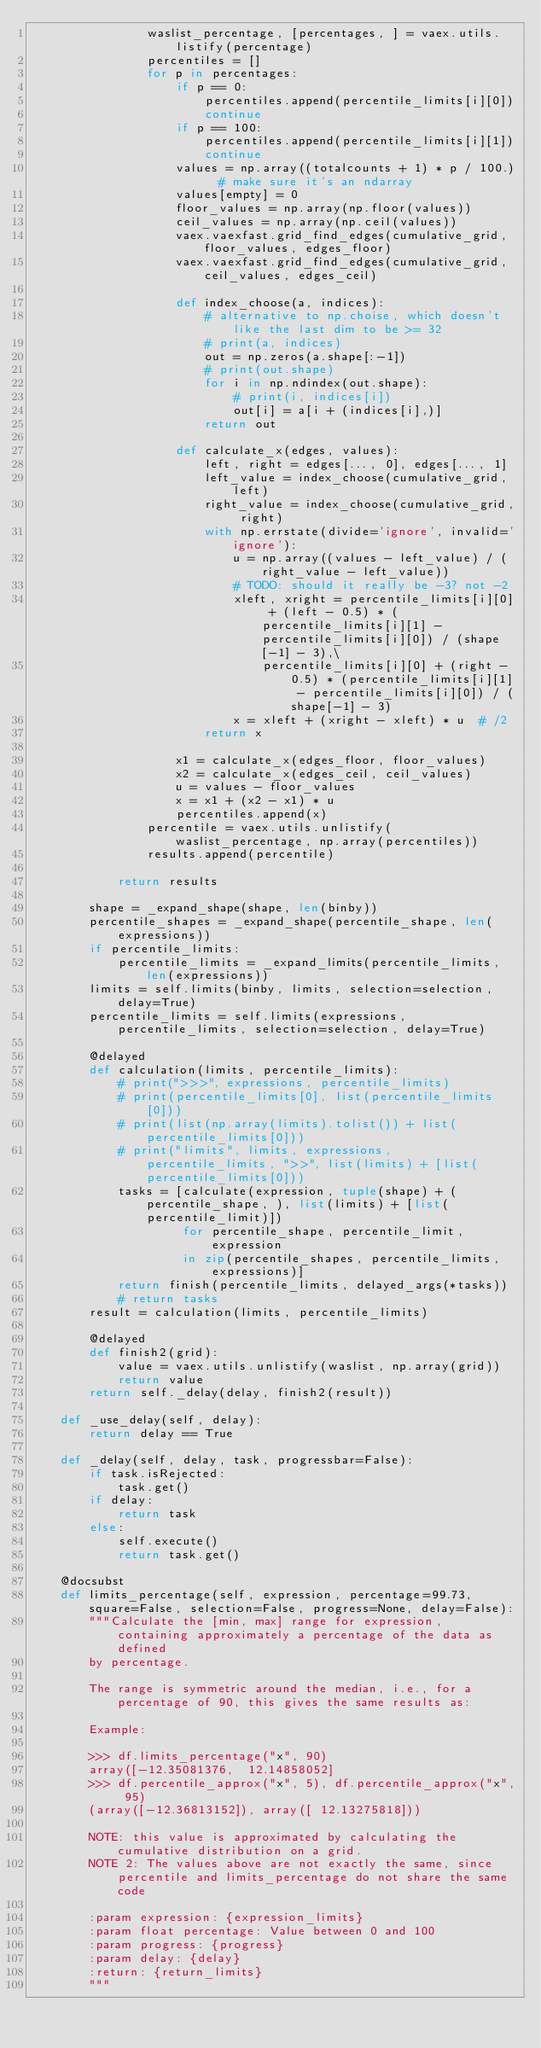<code> <loc_0><loc_0><loc_500><loc_500><_Python_>                waslist_percentage, [percentages, ] = vaex.utils.listify(percentage)
                percentiles = []
                for p in percentages:
                    if p == 0:
                        percentiles.append(percentile_limits[i][0])
                        continue
                    if p == 100:
                        percentiles.append(percentile_limits[i][1])
                        continue
                    values = np.array((totalcounts + 1) * p / 100.)  # make sure it's an ndarray
                    values[empty] = 0
                    floor_values = np.array(np.floor(values))
                    ceil_values = np.array(np.ceil(values))
                    vaex.vaexfast.grid_find_edges(cumulative_grid, floor_values, edges_floor)
                    vaex.vaexfast.grid_find_edges(cumulative_grid, ceil_values, edges_ceil)

                    def index_choose(a, indices):
                        # alternative to np.choise, which doesn't like the last dim to be >= 32
                        # print(a, indices)
                        out = np.zeros(a.shape[:-1])
                        # print(out.shape)
                        for i in np.ndindex(out.shape):
                            # print(i, indices[i])
                            out[i] = a[i + (indices[i],)]
                        return out

                    def calculate_x(edges, values):
                        left, right = edges[..., 0], edges[..., 1]
                        left_value = index_choose(cumulative_grid, left)
                        right_value = index_choose(cumulative_grid, right)
                        with np.errstate(divide='ignore', invalid='ignore'):
                            u = np.array((values - left_value) / (right_value - left_value))
                            # TODO: should it really be -3? not -2
                            xleft, xright = percentile_limits[i][0] + (left - 0.5) * (percentile_limits[i][1] - percentile_limits[i][0]) / (shape[-1] - 3),\
                                percentile_limits[i][0] + (right - 0.5) * (percentile_limits[i][1] - percentile_limits[i][0]) / (shape[-1] - 3)
                            x = xleft + (xright - xleft) * u  # /2
                        return x

                    x1 = calculate_x(edges_floor, floor_values)
                    x2 = calculate_x(edges_ceil, ceil_values)
                    u = values - floor_values
                    x = x1 + (x2 - x1) * u
                    percentiles.append(x)
                percentile = vaex.utils.unlistify(waslist_percentage, np.array(percentiles))
                results.append(percentile)

            return results

        shape = _expand_shape(shape, len(binby))
        percentile_shapes = _expand_shape(percentile_shape, len(expressions))
        if percentile_limits:
            percentile_limits = _expand_limits(percentile_limits, len(expressions))
        limits = self.limits(binby, limits, selection=selection, delay=True)
        percentile_limits = self.limits(expressions, percentile_limits, selection=selection, delay=True)

        @delayed
        def calculation(limits, percentile_limits):
            # print(">>>", expressions, percentile_limits)
            # print(percentile_limits[0], list(percentile_limits[0]))
            # print(list(np.array(limits).tolist()) + list(percentile_limits[0]))
            # print("limits", limits, expressions, percentile_limits, ">>", list(limits) + [list(percentile_limits[0]))
            tasks = [calculate(expression, tuple(shape) + (percentile_shape, ), list(limits) + [list(percentile_limit)])
                     for percentile_shape, percentile_limit, expression
                     in zip(percentile_shapes, percentile_limits, expressions)]
            return finish(percentile_limits, delayed_args(*tasks))
            # return tasks
        result = calculation(limits, percentile_limits)

        @delayed
        def finish2(grid):
            value = vaex.utils.unlistify(waslist, np.array(grid))
            return value
        return self._delay(delay, finish2(result))

    def _use_delay(self, delay):
        return delay == True

    def _delay(self, delay, task, progressbar=False):
        if task.isRejected:
            task.get()
        if delay:
            return task
        else:
            self.execute()
            return task.get()

    @docsubst
    def limits_percentage(self, expression, percentage=99.73, square=False, selection=False, progress=None, delay=False):
        """Calculate the [min, max] range for expression, containing approximately a percentage of the data as defined
        by percentage.

        The range is symmetric around the median, i.e., for a percentage of 90, this gives the same results as:

        Example:

        >>> df.limits_percentage("x", 90)
        array([-12.35081376,  12.14858052]
        >>> df.percentile_approx("x", 5), df.percentile_approx("x", 95)
        (array([-12.36813152]), array([ 12.13275818]))

        NOTE: this value is approximated by calculating the cumulative distribution on a grid.
        NOTE 2: The values above are not exactly the same, since percentile and limits_percentage do not share the same code

        :param expression: {expression_limits}
        :param float percentage: Value between 0 and 100
        :param progress: {progress}
        :param delay: {delay}
        :return: {return_limits}
        """</code> 